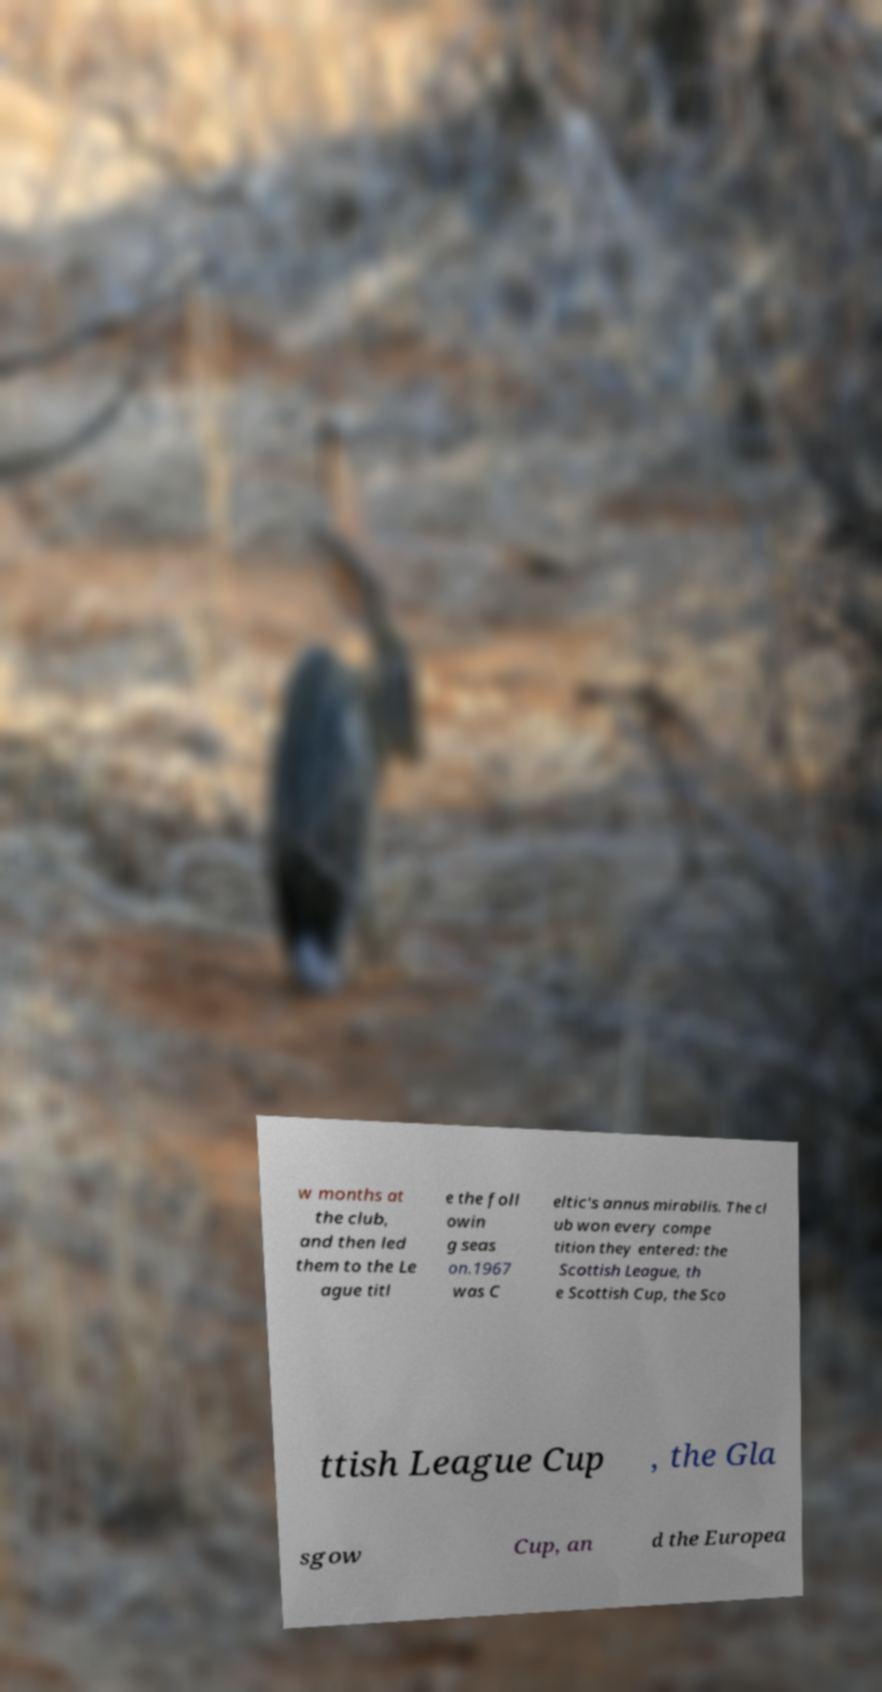There's text embedded in this image that I need extracted. Can you transcribe it verbatim? w months at the club, and then led them to the Le ague titl e the foll owin g seas on.1967 was C eltic's annus mirabilis. The cl ub won every compe tition they entered: the Scottish League, th e Scottish Cup, the Sco ttish League Cup , the Gla sgow Cup, an d the Europea 